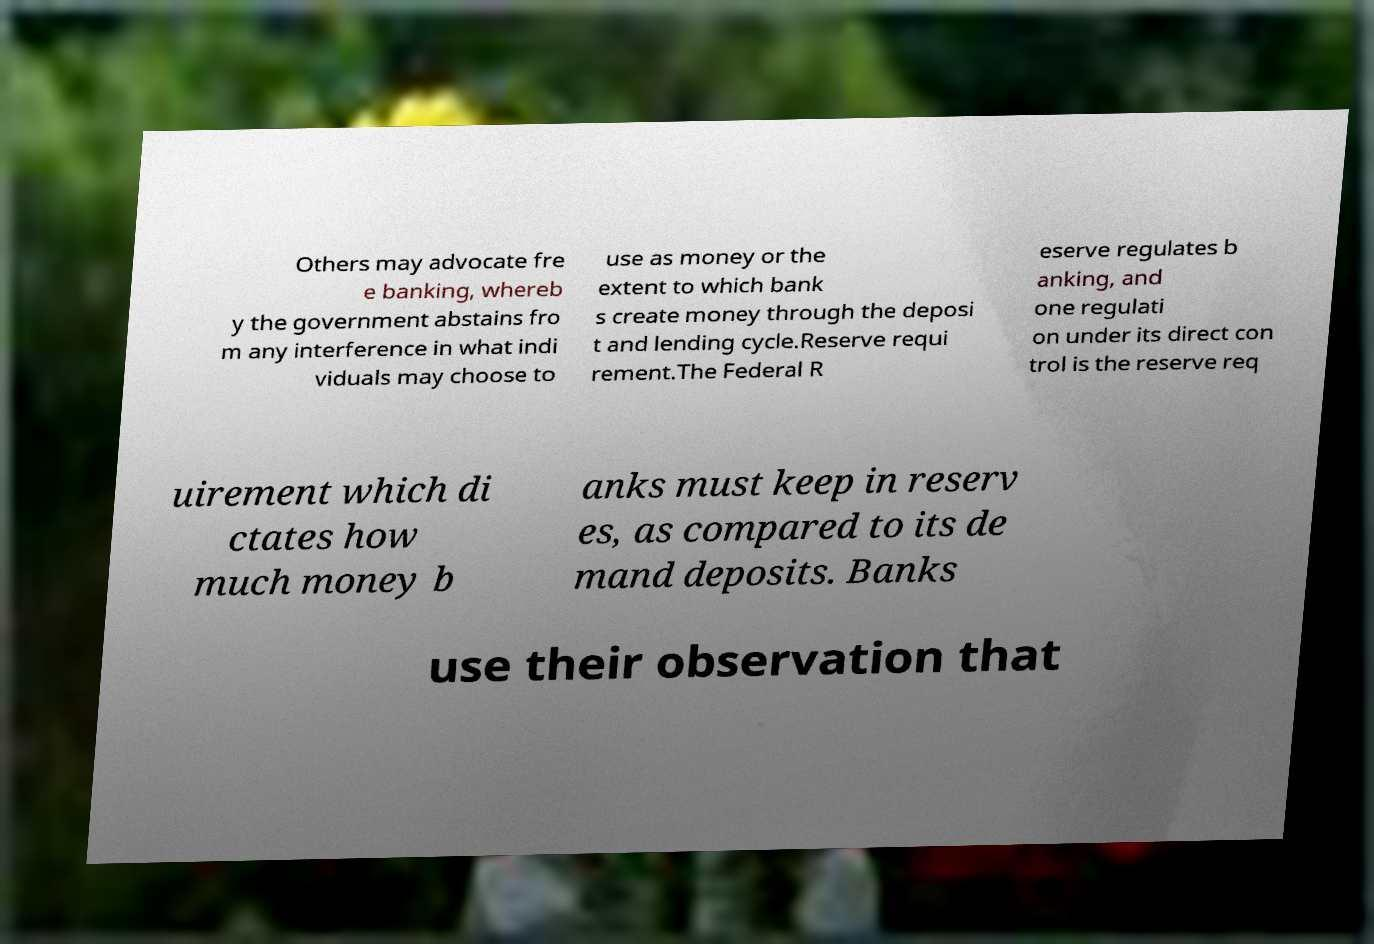There's text embedded in this image that I need extracted. Can you transcribe it verbatim? Others may advocate fre e banking, whereb y the government abstains fro m any interference in what indi viduals may choose to use as money or the extent to which bank s create money through the deposi t and lending cycle.Reserve requi rement.The Federal R eserve regulates b anking, and one regulati on under its direct con trol is the reserve req uirement which di ctates how much money b anks must keep in reserv es, as compared to its de mand deposits. Banks use their observation that 